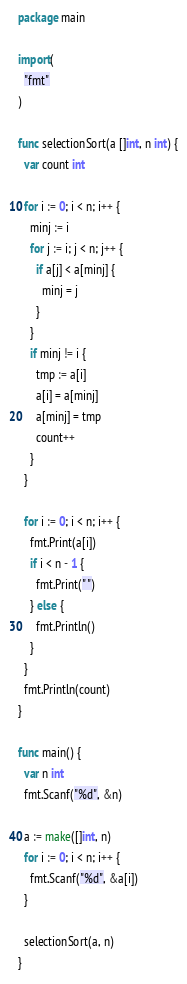Convert code to text. <code><loc_0><loc_0><loc_500><loc_500><_Go_>package main

import(
  "fmt"
)

func selectionSort(a []int, n int) {
  var count int

  for i := 0; i < n; i++ {
    minj := i
    for j := i; j < n; j++ {
      if a[j] < a[minj] {
        minj = j
      }
    }
    if minj != i {
      tmp := a[i]
      a[i] = a[minj]
      a[minj] = tmp
      count++
    }
  }

  for i := 0; i < n; i++ {
    fmt.Print(a[i])
    if i < n - 1 {
      fmt.Print(" ")
    } else {
      fmt.Println()
    }
  }
  fmt.Println(count)
}

func main() {
  var n int
  fmt.Scanf("%d", &n)

  a := make([]int, n)
  for i := 0; i < n; i++ {
    fmt.Scanf("%d", &a[i])
  }

  selectionSort(a, n)
}
</code> 